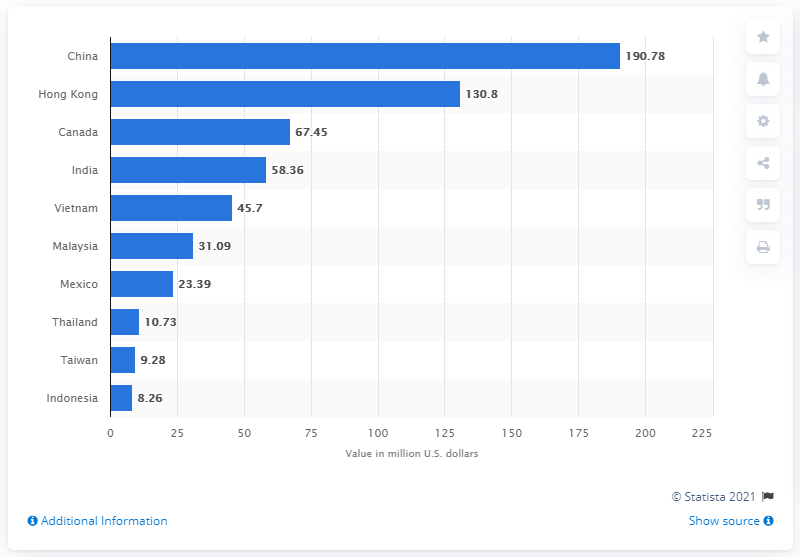Identify some key points in this picture. In 2017, the United States sent 190.78 metric tons of plastic scrap to China. 